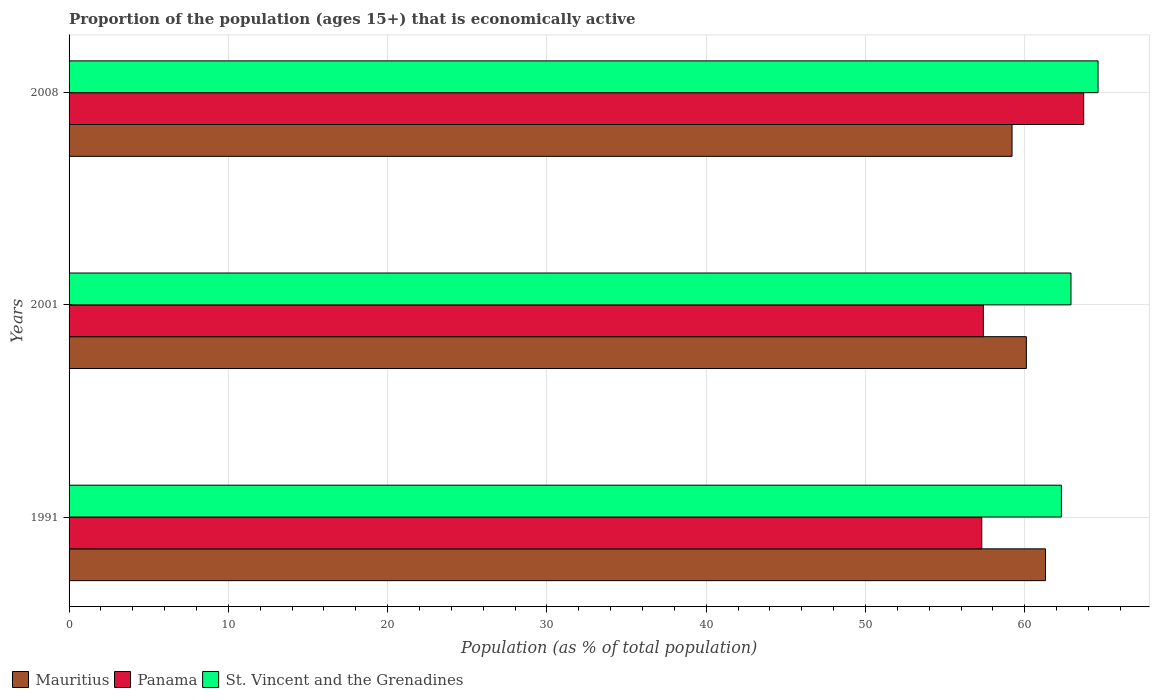How many groups of bars are there?
Offer a terse response. 3. How many bars are there on the 2nd tick from the top?
Ensure brevity in your answer.  3. How many bars are there on the 2nd tick from the bottom?
Offer a very short reply. 3. What is the label of the 1st group of bars from the top?
Your answer should be compact. 2008. What is the proportion of the population that is economically active in Panama in 2001?
Provide a short and direct response. 57.4. Across all years, what is the maximum proportion of the population that is economically active in Panama?
Your answer should be very brief. 63.7. Across all years, what is the minimum proportion of the population that is economically active in St. Vincent and the Grenadines?
Make the answer very short. 62.3. In which year was the proportion of the population that is economically active in Mauritius maximum?
Provide a succinct answer. 1991. In which year was the proportion of the population that is economically active in St. Vincent and the Grenadines minimum?
Make the answer very short. 1991. What is the total proportion of the population that is economically active in Panama in the graph?
Ensure brevity in your answer.  178.4. What is the difference between the proportion of the population that is economically active in St. Vincent and the Grenadines in 1991 and that in 2001?
Offer a terse response. -0.6. What is the difference between the proportion of the population that is economically active in Panama in 1991 and the proportion of the population that is economically active in Mauritius in 2001?
Make the answer very short. -2.8. What is the average proportion of the population that is economically active in Mauritius per year?
Ensure brevity in your answer.  60.2. In the year 1991, what is the difference between the proportion of the population that is economically active in St. Vincent and the Grenadines and proportion of the population that is economically active in Mauritius?
Keep it short and to the point. 1. In how many years, is the proportion of the population that is economically active in St. Vincent and the Grenadines greater than 28 %?
Offer a terse response. 3. What is the ratio of the proportion of the population that is economically active in Mauritius in 2001 to that in 2008?
Make the answer very short. 1.02. Is the proportion of the population that is economically active in Panama in 1991 less than that in 2001?
Make the answer very short. Yes. Is the difference between the proportion of the population that is economically active in St. Vincent and the Grenadines in 1991 and 2008 greater than the difference between the proportion of the population that is economically active in Mauritius in 1991 and 2008?
Your response must be concise. No. What is the difference between the highest and the second highest proportion of the population that is economically active in St. Vincent and the Grenadines?
Provide a succinct answer. 1.7. What is the difference between the highest and the lowest proportion of the population that is economically active in Mauritius?
Provide a short and direct response. 2.1. What does the 2nd bar from the top in 2008 represents?
Ensure brevity in your answer.  Panama. What does the 1st bar from the bottom in 2008 represents?
Give a very brief answer. Mauritius. Are all the bars in the graph horizontal?
Keep it short and to the point. Yes. What is the difference between two consecutive major ticks on the X-axis?
Your response must be concise. 10. Are the values on the major ticks of X-axis written in scientific E-notation?
Your answer should be very brief. No. Does the graph contain any zero values?
Your response must be concise. No. Where does the legend appear in the graph?
Offer a very short reply. Bottom left. What is the title of the graph?
Provide a short and direct response. Proportion of the population (ages 15+) that is economically active. Does "Nicaragua" appear as one of the legend labels in the graph?
Your answer should be very brief. No. What is the label or title of the X-axis?
Your answer should be very brief. Population (as % of total population). What is the Population (as % of total population) in Mauritius in 1991?
Provide a succinct answer. 61.3. What is the Population (as % of total population) of Panama in 1991?
Offer a terse response. 57.3. What is the Population (as % of total population) in St. Vincent and the Grenadines in 1991?
Offer a terse response. 62.3. What is the Population (as % of total population) of Mauritius in 2001?
Offer a terse response. 60.1. What is the Population (as % of total population) of Panama in 2001?
Make the answer very short. 57.4. What is the Population (as % of total population) of St. Vincent and the Grenadines in 2001?
Ensure brevity in your answer.  62.9. What is the Population (as % of total population) in Mauritius in 2008?
Ensure brevity in your answer.  59.2. What is the Population (as % of total population) of Panama in 2008?
Your answer should be compact. 63.7. What is the Population (as % of total population) of St. Vincent and the Grenadines in 2008?
Your answer should be compact. 64.6. Across all years, what is the maximum Population (as % of total population) of Mauritius?
Your response must be concise. 61.3. Across all years, what is the maximum Population (as % of total population) of Panama?
Make the answer very short. 63.7. Across all years, what is the maximum Population (as % of total population) in St. Vincent and the Grenadines?
Provide a short and direct response. 64.6. Across all years, what is the minimum Population (as % of total population) in Mauritius?
Offer a terse response. 59.2. Across all years, what is the minimum Population (as % of total population) in Panama?
Offer a terse response. 57.3. Across all years, what is the minimum Population (as % of total population) of St. Vincent and the Grenadines?
Offer a very short reply. 62.3. What is the total Population (as % of total population) in Mauritius in the graph?
Your answer should be compact. 180.6. What is the total Population (as % of total population) of Panama in the graph?
Offer a terse response. 178.4. What is the total Population (as % of total population) in St. Vincent and the Grenadines in the graph?
Offer a terse response. 189.8. What is the difference between the Population (as % of total population) in Mauritius in 1991 and that in 2001?
Provide a succinct answer. 1.2. What is the difference between the Population (as % of total population) in Panama in 1991 and that in 2001?
Provide a succinct answer. -0.1. What is the difference between the Population (as % of total population) of St. Vincent and the Grenadines in 1991 and that in 2001?
Your answer should be very brief. -0.6. What is the difference between the Population (as % of total population) in Mauritius in 1991 and that in 2008?
Make the answer very short. 2.1. What is the difference between the Population (as % of total population) of Panama in 1991 and that in 2008?
Make the answer very short. -6.4. What is the difference between the Population (as % of total population) of Panama in 2001 and that in 2008?
Provide a short and direct response. -6.3. What is the difference between the Population (as % of total population) of St. Vincent and the Grenadines in 2001 and that in 2008?
Keep it short and to the point. -1.7. What is the difference between the Population (as % of total population) of Mauritius in 1991 and the Population (as % of total population) of St. Vincent and the Grenadines in 2001?
Give a very brief answer. -1.6. What is the difference between the Population (as % of total population) in Mauritius in 1991 and the Population (as % of total population) in St. Vincent and the Grenadines in 2008?
Ensure brevity in your answer.  -3.3. What is the difference between the Population (as % of total population) in Mauritius in 2001 and the Population (as % of total population) in St. Vincent and the Grenadines in 2008?
Provide a short and direct response. -4.5. What is the difference between the Population (as % of total population) in Panama in 2001 and the Population (as % of total population) in St. Vincent and the Grenadines in 2008?
Ensure brevity in your answer.  -7.2. What is the average Population (as % of total population) of Mauritius per year?
Keep it short and to the point. 60.2. What is the average Population (as % of total population) of Panama per year?
Your response must be concise. 59.47. What is the average Population (as % of total population) in St. Vincent and the Grenadines per year?
Provide a succinct answer. 63.27. In the year 1991, what is the difference between the Population (as % of total population) of Mauritius and Population (as % of total population) of St. Vincent and the Grenadines?
Make the answer very short. -1. In the year 1991, what is the difference between the Population (as % of total population) of Panama and Population (as % of total population) of St. Vincent and the Grenadines?
Make the answer very short. -5. In the year 2001, what is the difference between the Population (as % of total population) in Mauritius and Population (as % of total population) in Panama?
Your answer should be compact. 2.7. In the year 2001, what is the difference between the Population (as % of total population) in Mauritius and Population (as % of total population) in St. Vincent and the Grenadines?
Ensure brevity in your answer.  -2.8. In the year 2008, what is the difference between the Population (as % of total population) of Mauritius and Population (as % of total population) of Panama?
Offer a very short reply. -4.5. In the year 2008, what is the difference between the Population (as % of total population) in Mauritius and Population (as % of total population) in St. Vincent and the Grenadines?
Provide a short and direct response. -5.4. In the year 2008, what is the difference between the Population (as % of total population) in Panama and Population (as % of total population) in St. Vincent and the Grenadines?
Ensure brevity in your answer.  -0.9. What is the ratio of the Population (as % of total population) in Mauritius in 1991 to that in 2008?
Provide a short and direct response. 1.04. What is the ratio of the Population (as % of total population) of Panama in 1991 to that in 2008?
Make the answer very short. 0.9. What is the ratio of the Population (as % of total population) in St. Vincent and the Grenadines in 1991 to that in 2008?
Your answer should be very brief. 0.96. What is the ratio of the Population (as % of total population) of Mauritius in 2001 to that in 2008?
Provide a succinct answer. 1.02. What is the ratio of the Population (as % of total population) in Panama in 2001 to that in 2008?
Offer a terse response. 0.9. What is the ratio of the Population (as % of total population) of St. Vincent and the Grenadines in 2001 to that in 2008?
Offer a terse response. 0.97. What is the difference between the highest and the second highest Population (as % of total population) of Panama?
Your answer should be compact. 6.3. What is the difference between the highest and the lowest Population (as % of total population) in Mauritius?
Your response must be concise. 2.1. What is the difference between the highest and the lowest Population (as % of total population) in Panama?
Your response must be concise. 6.4. 